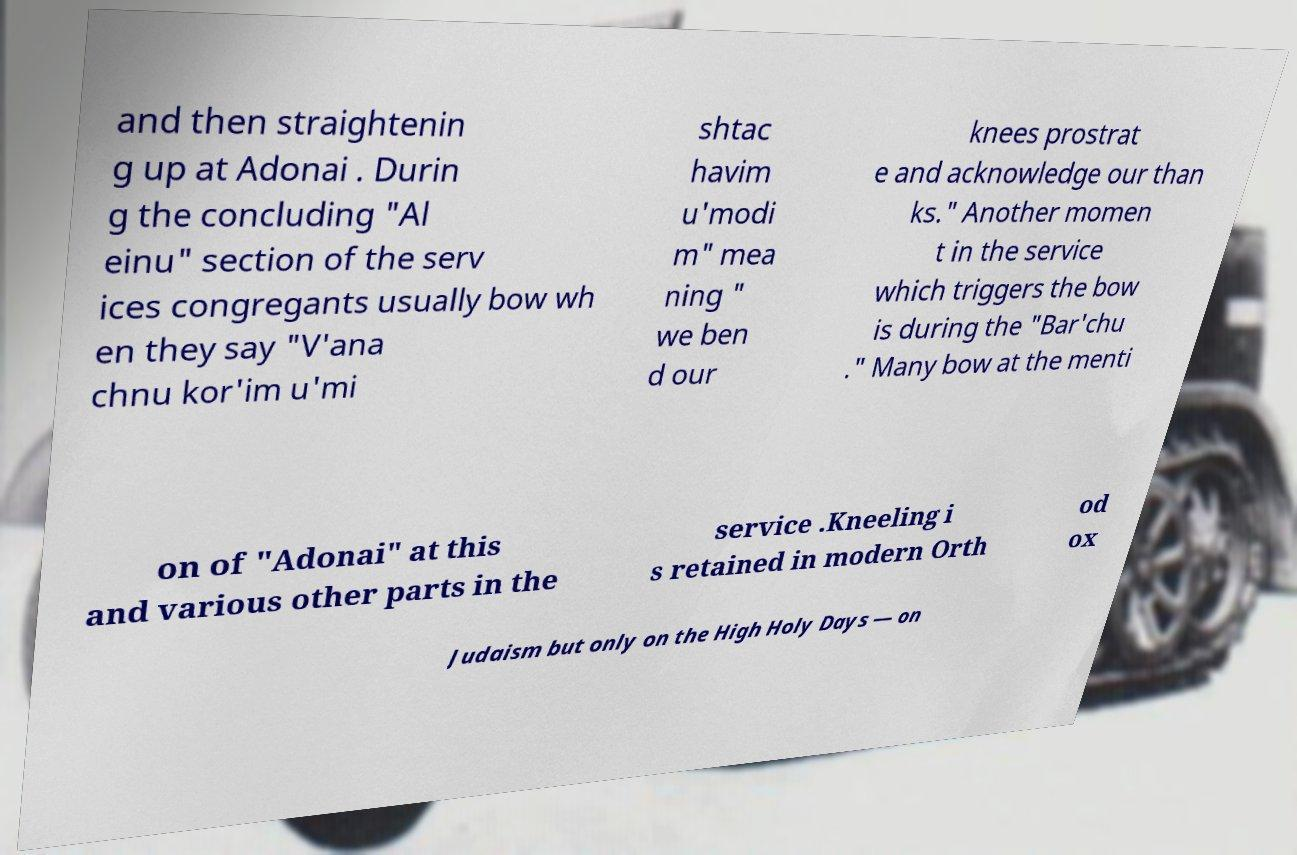Please read and relay the text visible in this image. What does it say? and then straightenin g up at Adonai . Durin g the concluding "Al einu" section of the serv ices congregants usually bow wh en they say "V'ana chnu kor'im u'mi shtac havim u'modi m" mea ning " we ben d our knees prostrat e and acknowledge our than ks." Another momen t in the service which triggers the bow is during the "Bar'chu ." Many bow at the menti on of "Adonai" at this and various other parts in the service .Kneeling i s retained in modern Orth od ox Judaism but only on the High Holy Days — on 